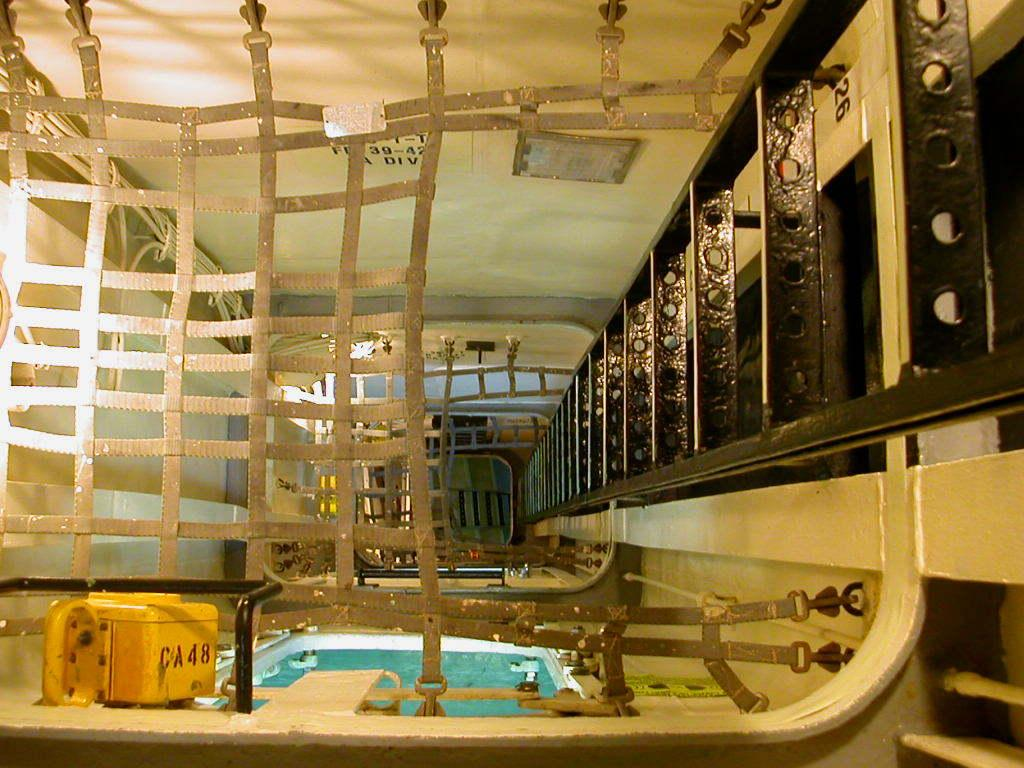What color is the box that is visible in the image? The box is yellow. What is written on the box in the image? "CA48" is written on the box. What can be seen in the background of the image? There is water and a wall visible in the image. What object is present in the image that might be used for climbing? There is a black ladder in the image. Can you see any wilderness in the image? No, there is no wilderness present in the image. Is there a fireman in the image? No, there is no fireman present in the image. 